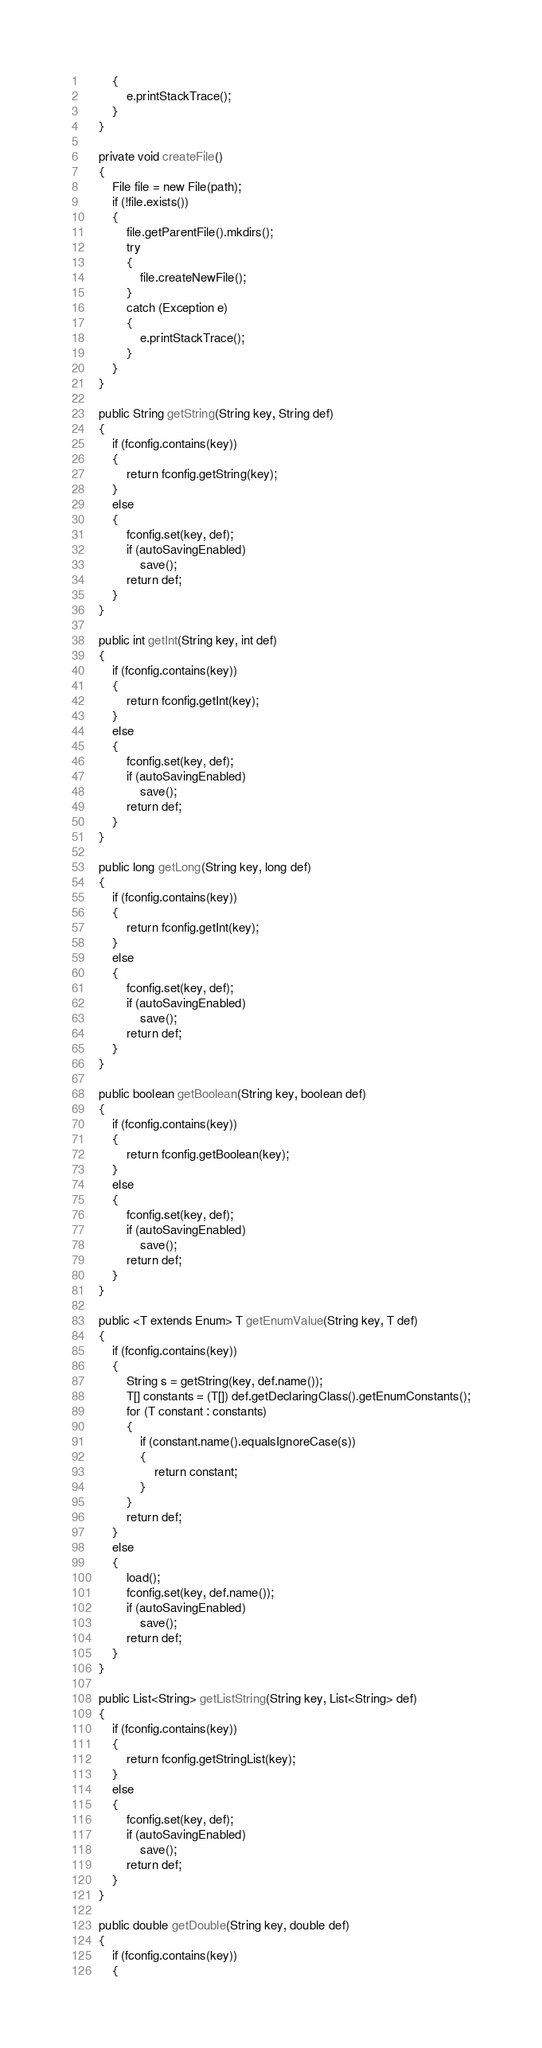<code> <loc_0><loc_0><loc_500><loc_500><_Java_>        {
            e.printStackTrace();
        }
    }

    private void createFile()
    {
        File file = new File(path);
        if (!file.exists())
        {
            file.getParentFile().mkdirs();
            try
            {
                file.createNewFile();
            }
            catch (Exception e)
            {
                e.printStackTrace();
            }
        }
    }

    public String getString(String key, String def)
    {
        if (fconfig.contains(key))
        {
            return fconfig.getString(key);
        }
        else
        {
            fconfig.set(key, def);
            if (autoSavingEnabled)
                save();
            return def;
        }
    }

    public int getInt(String key, int def)
    {
        if (fconfig.contains(key))
        {
            return fconfig.getInt(key);
        }
        else
        {
            fconfig.set(key, def);
            if (autoSavingEnabled)
                save();
            return def;
        }
    }

    public long getLong(String key, long def)
    {
        if (fconfig.contains(key))
        {
            return fconfig.getInt(key);
        }
        else
        {
            fconfig.set(key, def);
            if (autoSavingEnabled)
                save();
            return def;
        }
    }

    public boolean getBoolean(String key, boolean def)
    {
        if (fconfig.contains(key))
        {
            return fconfig.getBoolean(key);
        }
        else
        {
            fconfig.set(key, def);
            if (autoSavingEnabled)
                save();
            return def;
        }
    }

    public <T extends Enum> T getEnumValue(String key, T def)
    {
        if (fconfig.contains(key))
        {
            String s = getString(key, def.name());
            T[] constants = (T[]) def.getDeclaringClass().getEnumConstants();
            for (T constant : constants)
            {
                if (constant.name().equalsIgnoreCase(s))
                {
                    return constant;
                }
            }
            return def;
        }
        else
        {
            load();
            fconfig.set(key, def.name());
            if (autoSavingEnabled)
                save();
            return def;
        }
    }

    public List<String> getListString(String key, List<String> def)
    {
        if (fconfig.contains(key))
        {
            return fconfig.getStringList(key);
        }
        else
        {
            fconfig.set(key, def);
            if (autoSavingEnabled)
                save();
            return def;
        }
    }

    public double getDouble(String key, double def)
    {
        if (fconfig.contains(key))
        {</code> 